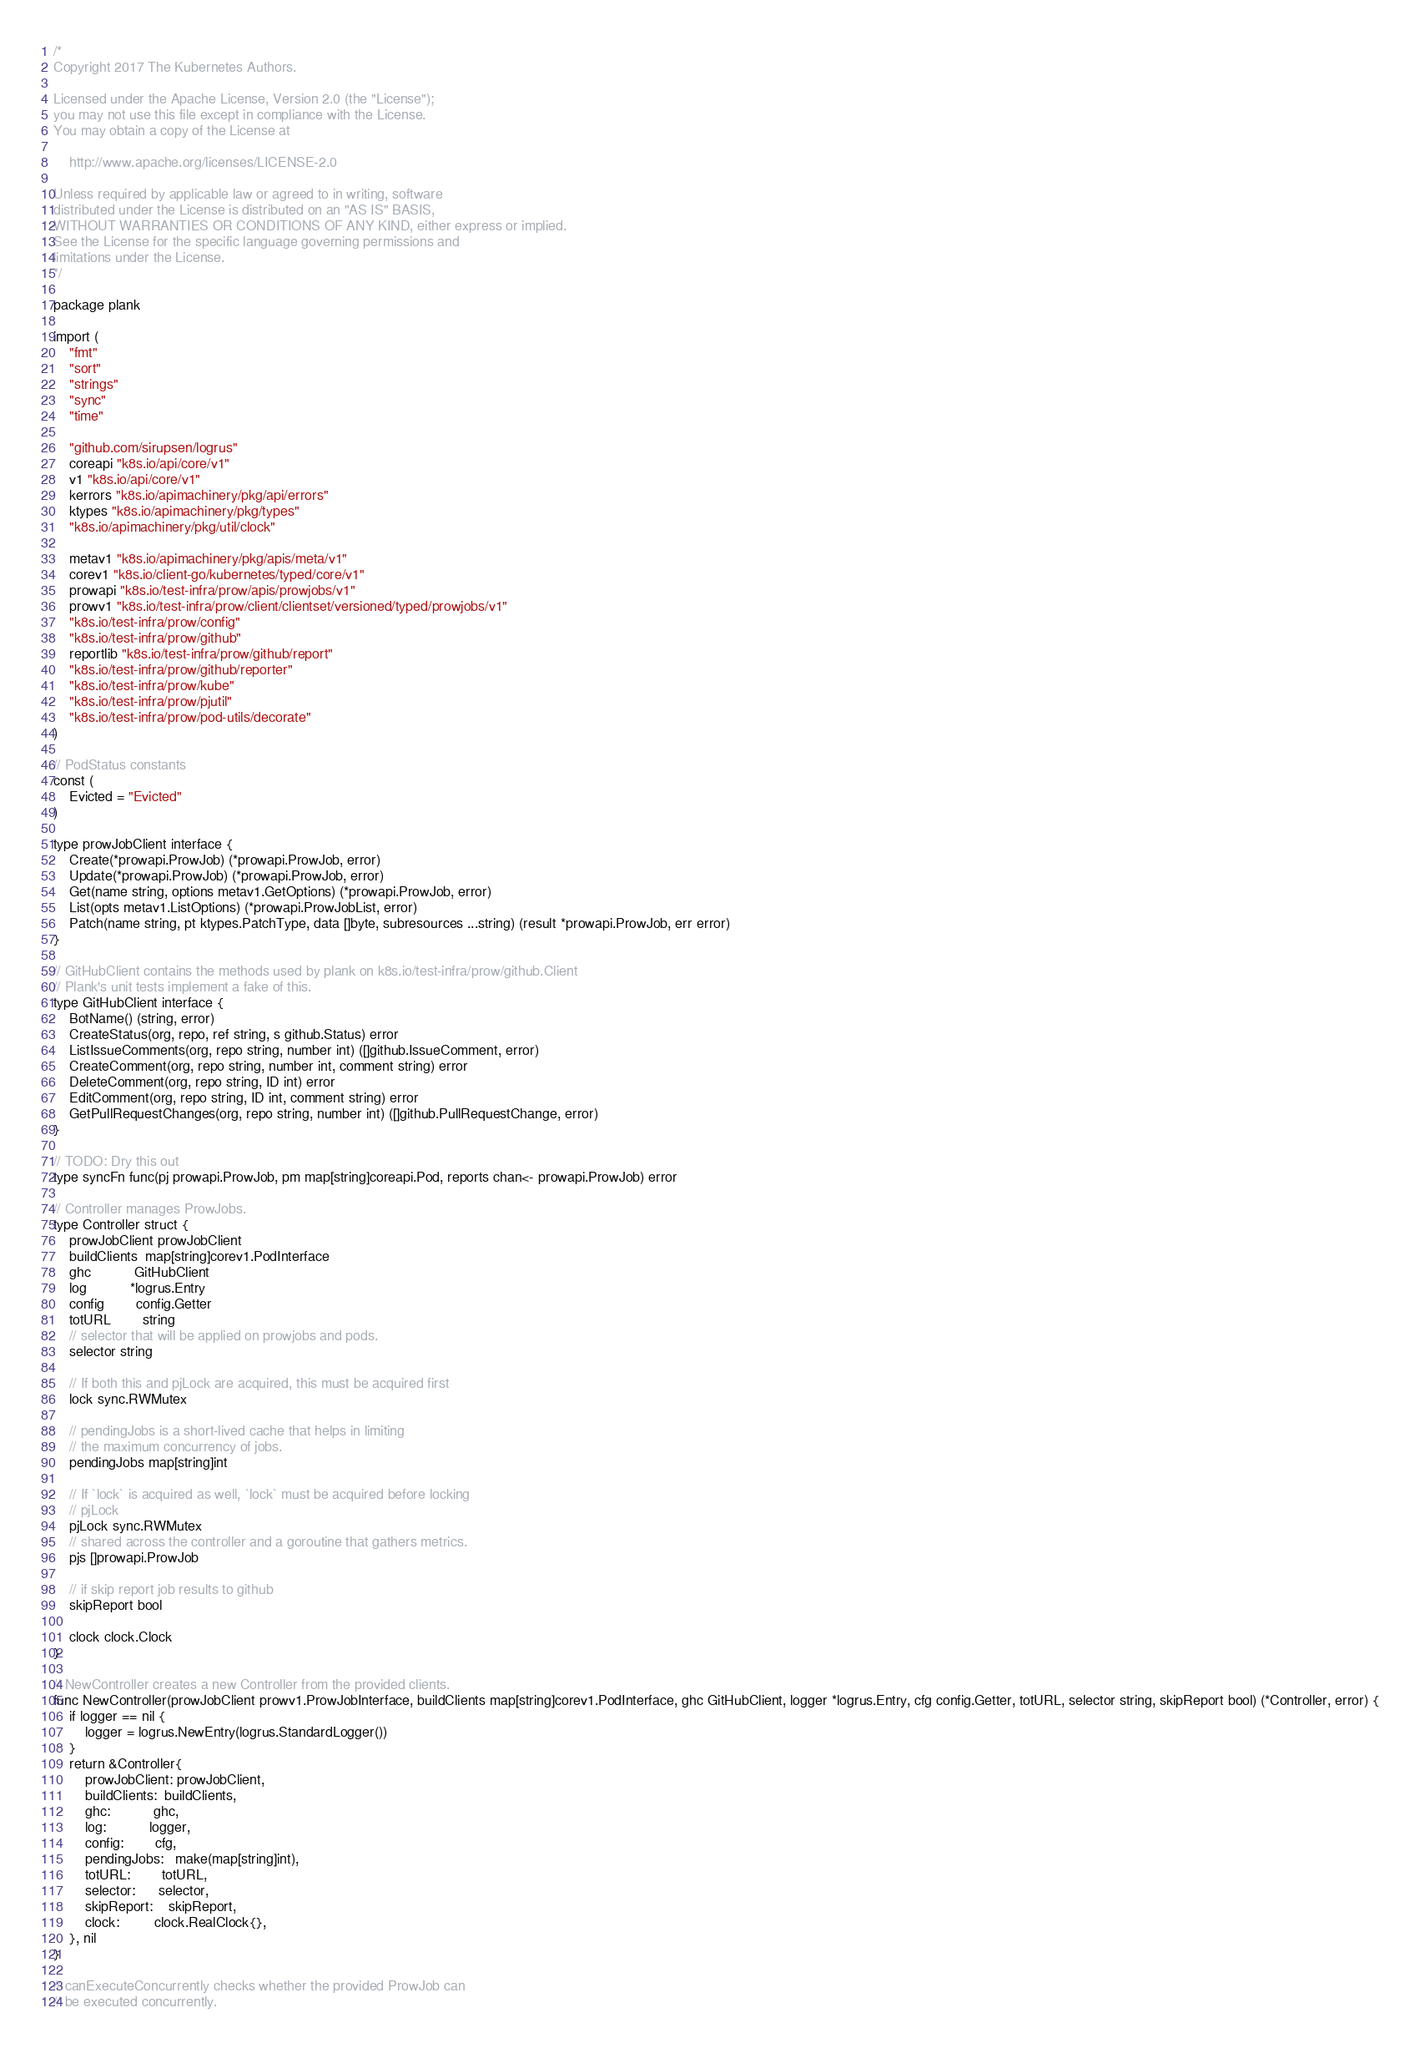<code> <loc_0><loc_0><loc_500><loc_500><_Go_>/*
Copyright 2017 The Kubernetes Authors.

Licensed under the Apache License, Version 2.0 (the "License");
you may not use this file except in compliance with the License.
You may obtain a copy of the License at

    http://www.apache.org/licenses/LICENSE-2.0

Unless required by applicable law or agreed to in writing, software
distributed under the License is distributed on an "AS IS" BASIS,
WITHOUT WARRANTIES OR CONDITIONS OF ANY KIND, either express or implied.
See the License for the specific language governing permissions and
limitations under the License.
*/

package plank

import (
	"fmt"
	"sort"
	"strings"
	"sync"
	"time"

	"github.com/sirupsen/logrus"
	coreapi "k8s.io/api/core/v1"
	v1 "k8s.io/api/core/v1"
	kerrors "k8s.io/apimachinery/pkg/api/errors"
	ktypes "k8s.io/apimachinery/pkg/types"
	"k8s.io/apimachinery/pkg/util/clock"

	metav1 "k8s.io/apimachinery/pkg/apis/meta/v1"
	corev1 "k8s.io/client-go/kubernetes/typed/core/v1"
	prowapi "k8s.io/test-infra/prow/apis/prowjobs/v1"
	prowv1 "k8s.io/test-infra/prow/client/clientset/versioned/typed/prowjobs/v1"
	"k8s.io/test-infra/prow/config"
	"k8s.io/test-infra/prow/github"
	reportlib "k8s.io/test-infra/prow/github/report"
	"k8s.io/test-infra/prow/github/reporter"
	"k8s.io/test-infra/prow/kube"
	"k8s.io/test-infra/prow/pjutil"
	"k8s.io/test-infra/prow/pod-utils/decorate"
)

// PodStatus constants
const (
	Evicted = "Evicted"
)

type prowJobClient interface {
	Create(*prowapi.ProwJob) (*prowapi.ProwJob, error)
	Update(*prowapi.ProwJob) (*prowapi.ProwJob, error)
	Get(name string, options metav1.GetOptions) (*prowapi.ProwJob, error)
	List(opts metav1.ListOptions) (*prowapi.ProwJobList, error)
	Patch(name string, pt ktypes.PatchType, data []byte, subresources ...string) (result *prowapi.ProwJob, err error)
}

// GitHubClient contains the methods used by plank on k8s.io/test-infra/prow/github.Client
// Plank's unit tests implement a fake of this.
type GitHubClient interface {
	BotName() (string, error)
	CreateStatus(org, repo, ref string, s github.Status) error
	ListIssueComments(org, repo string, number int) ([]github.IssueComment, error)
	CreateComment(org, repo string, number int, comment string) error
	DeleteComment(org, repo string, ID int) error
	EditComment(org, repo string, ID int, comment string) error
	GetPullRequestChanges(org, repo string, number int) ([]github.PullRequestChange, error)
}

// TODO: Dry this out
type syncFn func(pj prowapi.ProwJob, pm map[string]coreapi.Pod, reports chan<- prowapi.ProwJob) error

// Controller manages ProwJobs.
type Controller struct {
	prowJobClient prowJobClient
	buildClients  map[string]corev1.PodInterface
	ghc           GitHubClient
	log           *logrus.Entry
	config        config.Getter
	totURL        string
	// selector that will be applied on prowjobs and pods.
	selector string

	// If both this and pjLock are acquired, this must be acquired first
	lock sync.RWMutex

	// pendingJobs is a short-lived cache that helps in limiting
	// the maximum concurrency of jobs.
	pendingJobs map[string]int

	// If `lock` is acquired as well, `lock` must be acquired before locking
	// pjLock
	pjLock sync.RWMutex
	// shared across the controller and a goroutine that gathers metrics.
	pjs []prowapi.ProwJob

	// if skip report job results to github
	skipReport bool

	clock clock.Clock
}

// NewController creates a new Controller from the provided clients.
func NewController(prowJobClient prowv1.ProwJobInterface, buildClients map[string]corev1.PodInterface, ghc GitHubClient, logger *logrus.Entry, cfg config.Getter, totURL, selector string, skipReport bool) (*Controller, error) {
	if logger == nil {
		logger = logrus.NewEntry(logrus.StandardLogger())
	}
	return &Controller{
		prowJobClient: prowJobClient,
		buildClients:  buildClients,
		ghc:           ghc,
		log:           logger,
		config:        cfg,
		pendingJobs:   make(map[string]int),
		totURL:        totURL,
		selector:      selector,
		skipReport:    skipReport,
		clock:         clock.RealClock{},
	}, nil
}

// canExecuteConcurrently checks whether the provided ProwJob can
// be executed concurrently.</code> 